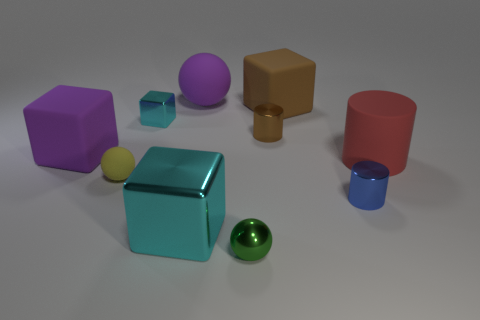Which objects in the image could float on water? Based on their appearance, objects that appear hollow or made of materials with a density lower than water, such as the red cylinder or the purple cube, if hollow, could potentially float on water. 